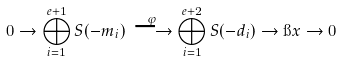<formula> <loc_0><loc_0><loc_500><loc_500>0 \to \bigoplus _ { i = 1 } ^ { e + 1 } S ( - m _ { i } ) \, \stackrel { \varphi } { \longrightarrow } \bigoplus _ { i = 1 } ^ { e + 2 } S ( - d _ { i } ) \to \i x \to 0</formula> 